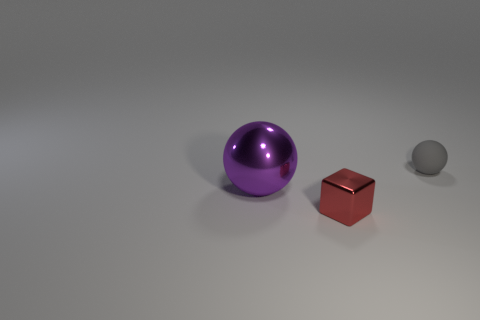Add 3 small brown rubber cubes. How many objects exist? 6 Subtract all blocks. How many objects are left? 2 Add 3 small gray cubes. How many small gray cubes exist? 3 Subtract 0 brown spheres. How many objects are left? 3 Subtract all small red blocks. Subtract all purple rubber things. How many objects are left? 2 Add 1 metal objects. How many metal objects are left? 3 